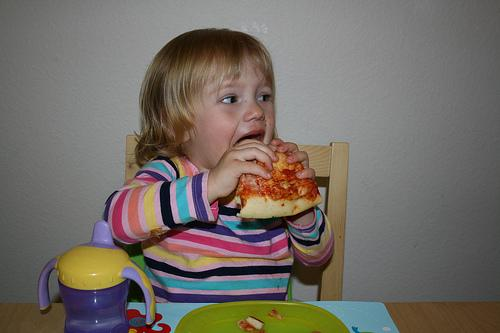Identify the type and color of the shirt the child is wearing. The child is wearing a colorful striped shirt. Briefly describe the main setting and background of the image.  The image is set at a tan wooden table with a white or gray wall behind the child. Point out an item in the image that has a specific design and describe it. The blue place mat has a red design. Assess the overall sentiment or emotion portrayed in this image. The sentiment is joyful and casual as a young child enjoys her pizza. What kind of table is the child sitting at, and what color is it? The child is sitting at a brown wooden table. How many unique objects or entities can be identified in the image? 15 unique objects/entities can be identified in the image. Mention the object on the table with its color and type. There is a lavender and yellow toddler's sippy cup on the table. What is the primary activity happening in this image?  A toddler girl eating a slice of pizza. List three objects that can be found on the table. A sippy cup, a slice of pizza, and a green oval plate. Provide a complex reasoning task based on the image by identifying a possible cause-and-effect scenario. The toddler eating pizza might have caused pizza sauce to stain her shirt sleeve. 